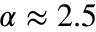<formula> <loc_0><loc_0><loc_500><loc_500>\alpha \approx 2 . 5</formula> 